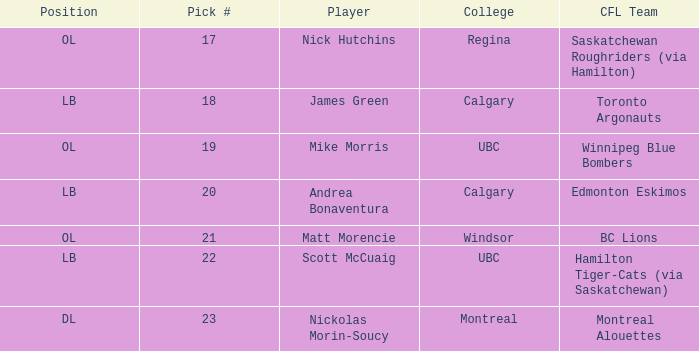What position is the player who went to Regina?  OL. 